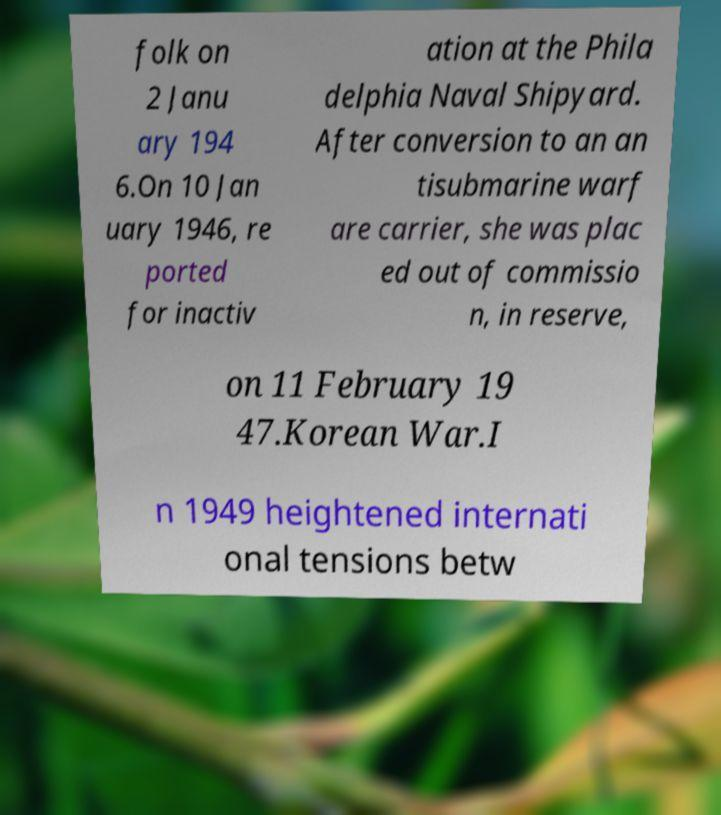For documentation purposes, I need the text within this image transcribed. Could you provide that? folk on 2 Janu ary 194 6.On 10 Jan uary 1946, re ported for inactiv ation at the Phila delphia Naval Shipyard. After conversion to an an tisubmarine warf are carrier, she was plac ed out of commissio n, in reserve, on 11 February 19 47.Korean War.I n 1949 heightened internati onal tensions betw 